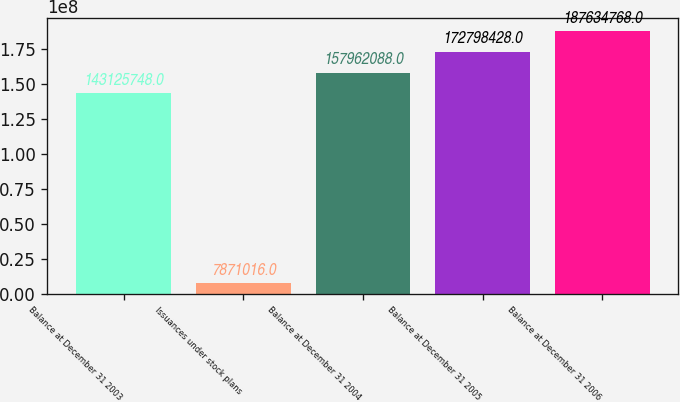<chart> <loc_0><loc_0><loc_500><loc_500><bar_chart><fcel>Balance at December 31 2003<fcel>Issuances under stock plans<fcel>Balance at December 31 2004<fcel>Balance at December 31 2005<fcel>Balance at December 31 2006<nl><fcel>1.43126e+08<fcel>7.87102e+06<fcel>1.57962e+08<fcel>1.72798e+08<fcel>1.87635e+08<nl></chart> 